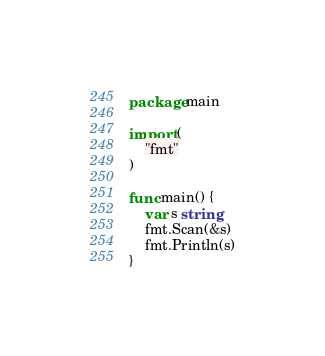Convert code to text. <code><loc_0><loc_0><loc_500><loc_500><_Go_>package main

import (
	"fmt"
)

func main() {
	var s string
	fmt.Scan(&s)
	fmt.Println(s)
}
</code> 